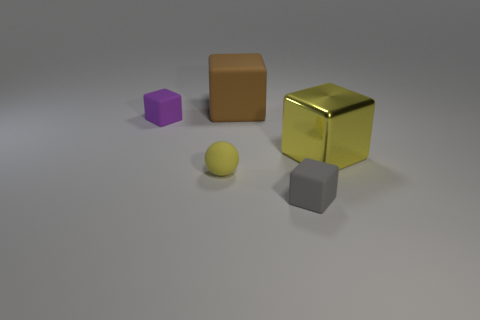Add 2 tiny red spheres. How many objects exist? 7 Subtract all balls. How many objects are left? 4 Add 5 small cubes. How many small cubes exist? 7 Subtract 0 cyan cylinders. How many objects are left? 5 Subtract all small yellow rubber things. Subtract all gray cubes. How many objects are left? 3 Add 2 purple matte blocks. How many purple matte blocks are left? 3 